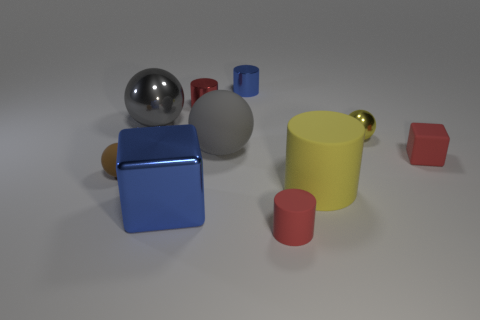Do the large blue cube and the small yellow thing have the same material?
Your answer should be compact. Yes. What material is the blue thing that is the same size as the yellow cylinder?
Offer a terse response. Metal. What number of objects are either spheres in front of the red block or big blue cubes?
Keep it short and to the point. 2. Are there an equal number of tiny red objects on the right side of the yellow cylinder and small purple metal cylinders?
Provide a short and direct response. No. Is the big block the same color as the tiny rubber ball?
Your answer should be very brief. No. There is a tiny object that is both in front of the small shiny sphere and on the right side of the big yellow cylinder; what is its color?
Your answer should be very brief. Red. What number of cylinders are either large rubber objects or small yellow things?
Provide a short and direct response. 1. Is the number of shiny spheres behind the blue metallic cylinder less than the number of large yellow rubber cylinders?
Give a very brief answer. Yes. There is a yellow thing that is the same material as the brown sphere; what is its shape?
Your answer should be compact. Cylinder. What number of small rubber things are the same color as the small matte cube?
Provide a short and direct response. 1. 